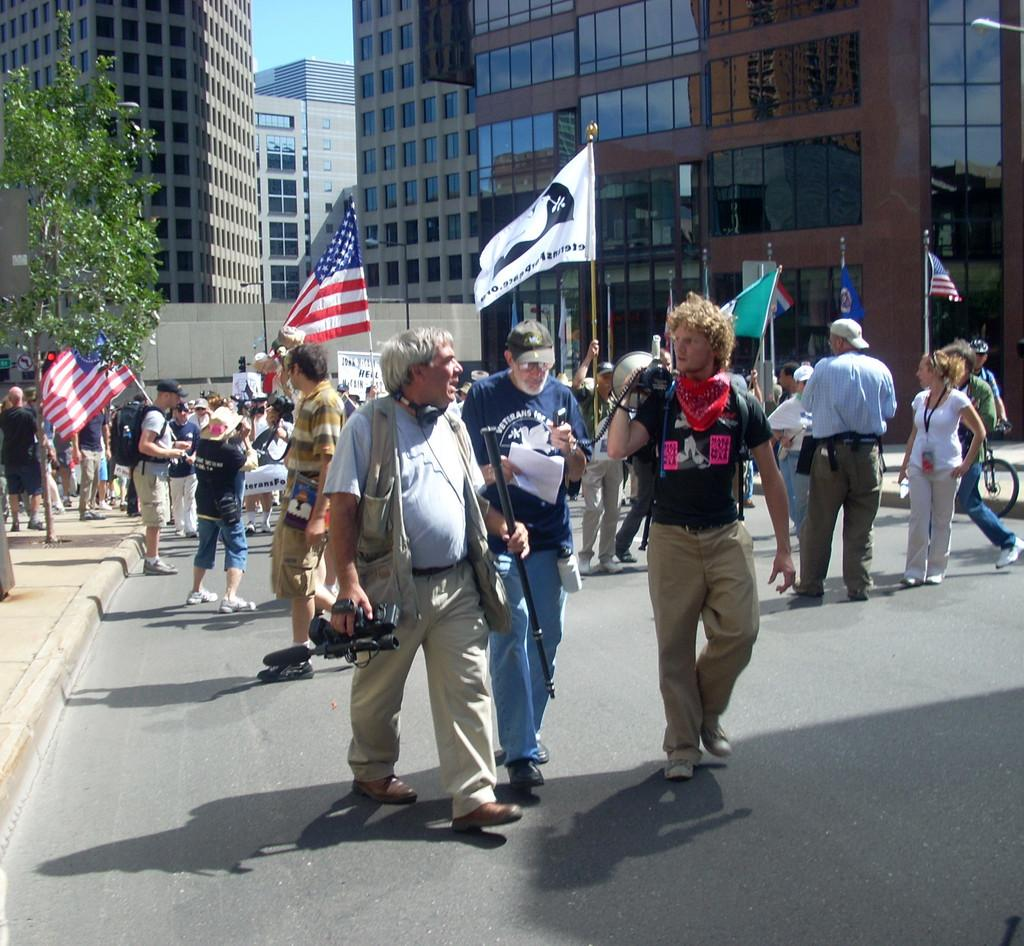What are the people in the image doing? The people in the image are standing in the middle of the image. What are the people holding in their hands? The people are holding something in their hands. Where are the people walking? The people are walking on a road. What can be seen behind the people? There are trees, poles, flags, and buildings in the background. Can you tell me how many rabbits are hopping around the people in the image? There are no rabbits present in the image; it only features people walking on a road with various background elements. What is the team's strategy for winning the game in the image? There is no game or team present in the image; it only shows people walking on a road. 